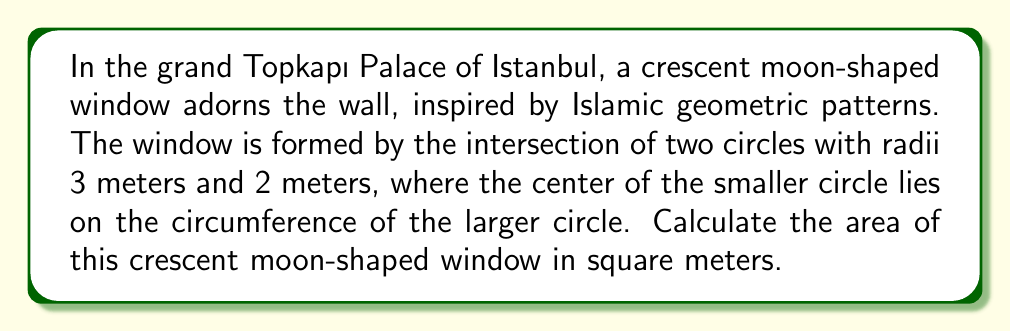Help me with this question. Let's approach this step-by-step:

1) The crescent moon shape is formed by subtracting the area of the lens-shaped intersection from the area of the larger circle.

2) Area of the larger circle:
   $A_1 = \pi r_1^2 = \pi \cdot 3^2 = 9\pi$ m²

3) To find the area of the lens-shaped intersection, we need to calculate the central angle of the sector in the larger circle:
   $\cos \theta = \frac{r_1 - r_2}{r_1} = \frac{3 - 2}{3} = \frac{1}{3}$
   $\theta = \arccos(\frac{1}{3}) \approx 1.2309$ radians

4) Area of the sector in the larger circle:
   $A_{sector1} = \frac{1}{2} r_1^2 \theta = \frac{1}{2} \cdot 3^2 \cdot 1.2309 = 5.5391$ m²

5) Area of the triangle in the larger circle:
   $A_{triangle1} = \frac{1}{2} r_1^2 \sin \theta = \frac{1}{2} \cdot 3^2 \cdot \sin(1.2309) = 3.8971$ m²

6) Area of the sector in the smaller circle:
   $A_{sector2} = \frac{1}{2} r_2^2 \theta = \frac{1}{2} \cdot 2^2 \cdot 1.2309 = 2.4618$ m²

7) Area of the triangle in the smaller circle:
   $A_{triangle2} = \frac{1}{2} r_2^2 \sin \theta = \frac{1}{2} \cdot 2^2 \cdot \sin(1.2309) = 1.7320$ m²

8) Area of the lens-shaped intersection:
   $A_{lens} = (A_{sector1} - A_{triangle1}) + (A_{sector2} - A_{triangle2})$
   $= (5.5391 - 3.8971) + (2.4618 - 1.7320) = 2.3718$ m²

9) Area of the crescent moon shape:
   $A_{crescent} = A_1 - A_{lens} = 9\pi - 2.3718 \approx 25.9027$ m²

[asy]
unitsize(30);
draw(circle((0,0),3));
draw(circle((3,0),2));
fill(circle((0,0),3)--arc((3,0),2,180,360)--cycle,gray(0.7));
label("3m",(0,1.5),W);
label("2m",(3,1),E);
[/asy]
Answer: $25.9027$ m² 